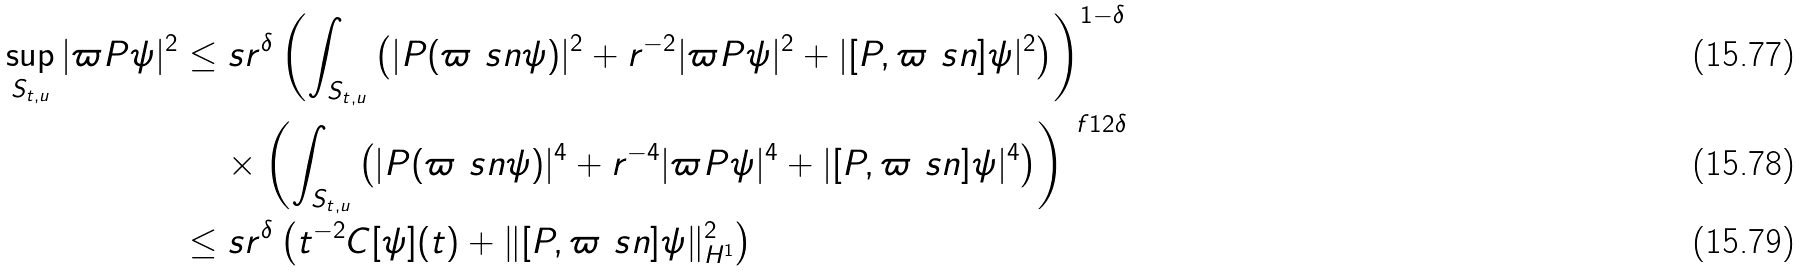<formula> <loc_0><loc_0><loc_500><loc_500>\sup _ { S _ { t , u } } | \varpi P \psi | ^ { 2 } & \leq s r ^ { \delta } \left ( \int _ { S _ { t , u } } \left ( | P ( \varpi \ s n \psi ) | ^ { 2 } + r ^ { - 2 } | \varpi P \psi | ^ { 2 } + | [ P , \varpi \ s n ] \psi | ^ { 2 } \right ) \right ) ^ { 1 - \delta } \\ & \quad \, \times \left ( \int _ { S _ { t , u } } \left ( | P ( \varpi \ s n \psi ) | ^ { 4 } + r ^ { - 4 } | \varpi P \psi | ^ { 4 } + | [ P , \varpi \ s n ] \psi | ^ { 4 } \right ) \right ) ^ { \ f 1 2 \delta } \\ & \leq s r ^ { \delta } \left ( t ^ { - 2 } C [ \psi ] ( t ) + \| [ P , \varpi \ s n ] \psi \| ^ { 2 } _ { H ^ { 1 } } \right )</formula> 